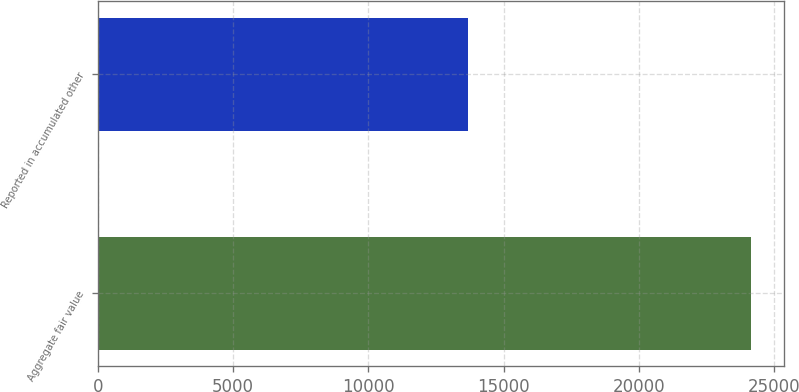<chart> <loc_0><loc_0><loc_500><loc_500><bar_chart><fcel>Aggregate fair value<fcel>Reported in accumulated other<nl><fcel>24151<fcel>13678<nl></chart> 